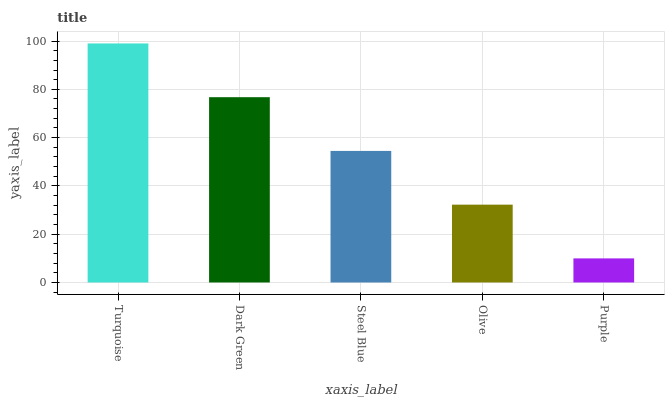Is Purple the minimum?
Answer yes or no. Yes. Is Turquoise the maximum?
Answer yes or no. Yes. Is Dark Green the minimum?
Answer yes or no. No. Is Dark Green the maximum?
Answer yes or no. No. Is Turquoise greater than Dark Green?
Answer yes or no. Yes. Is Dark Green less than Turquoise?
Answer yes or no. Yes. Is Dark Green greater than Turquoise?
Answer yes or no. No. Is Turquoise less than Dark Green?
Answer yes or no. No. Is Steel Blue the high median?
Answer yes or no. Yes. Is Steel Blue the low median?
Answer yes or no. Yes. Is Turquoise the high median?
Answer yes or no. No. Is Dark Green the low median?
Answer yes or no. No. 